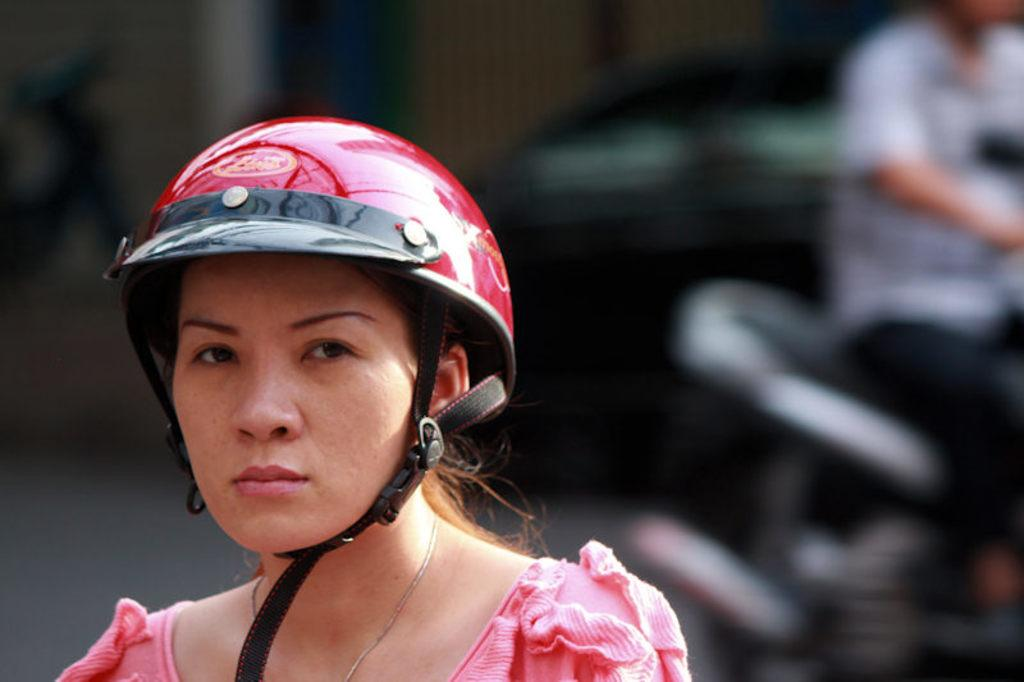Who is present in the image? There is a woman in the image. What is the woman wearing on her head? The woman is wearing a helmet. What is the person in the image doing? There is a person riding a vehicle in the image. How would you describe the background of the image? The background of the image is blurred. What type of property does the woman own in the image? There is no information about property ownership in the image. 